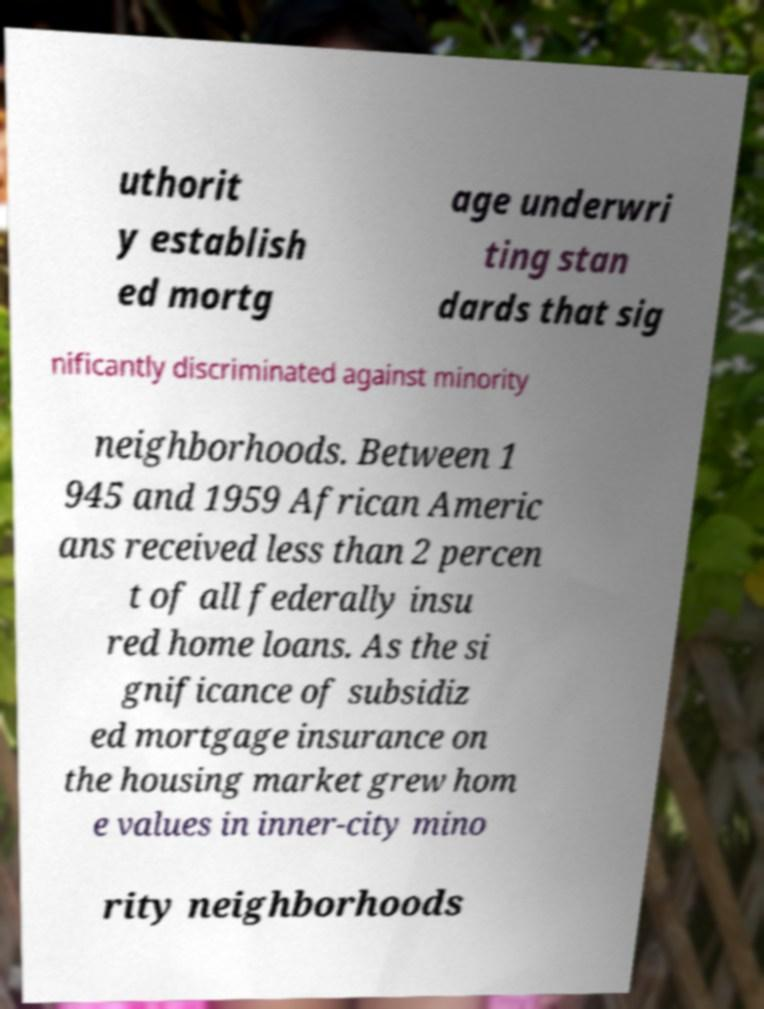Can you accurately transcribe the text from the provided image for me? uthorit y establish ed mortg age underwri ting stan dards that sig nificantly discriminated against minority neighborhoods. Between 1 945 and 1959 African Americ ans received less than 2 percen t of all federally insu red home loans. As the si gnificance of subsidiz ed mortgage insurance on the housing market grew hom e values in inner-city mino rity neighborhoods 